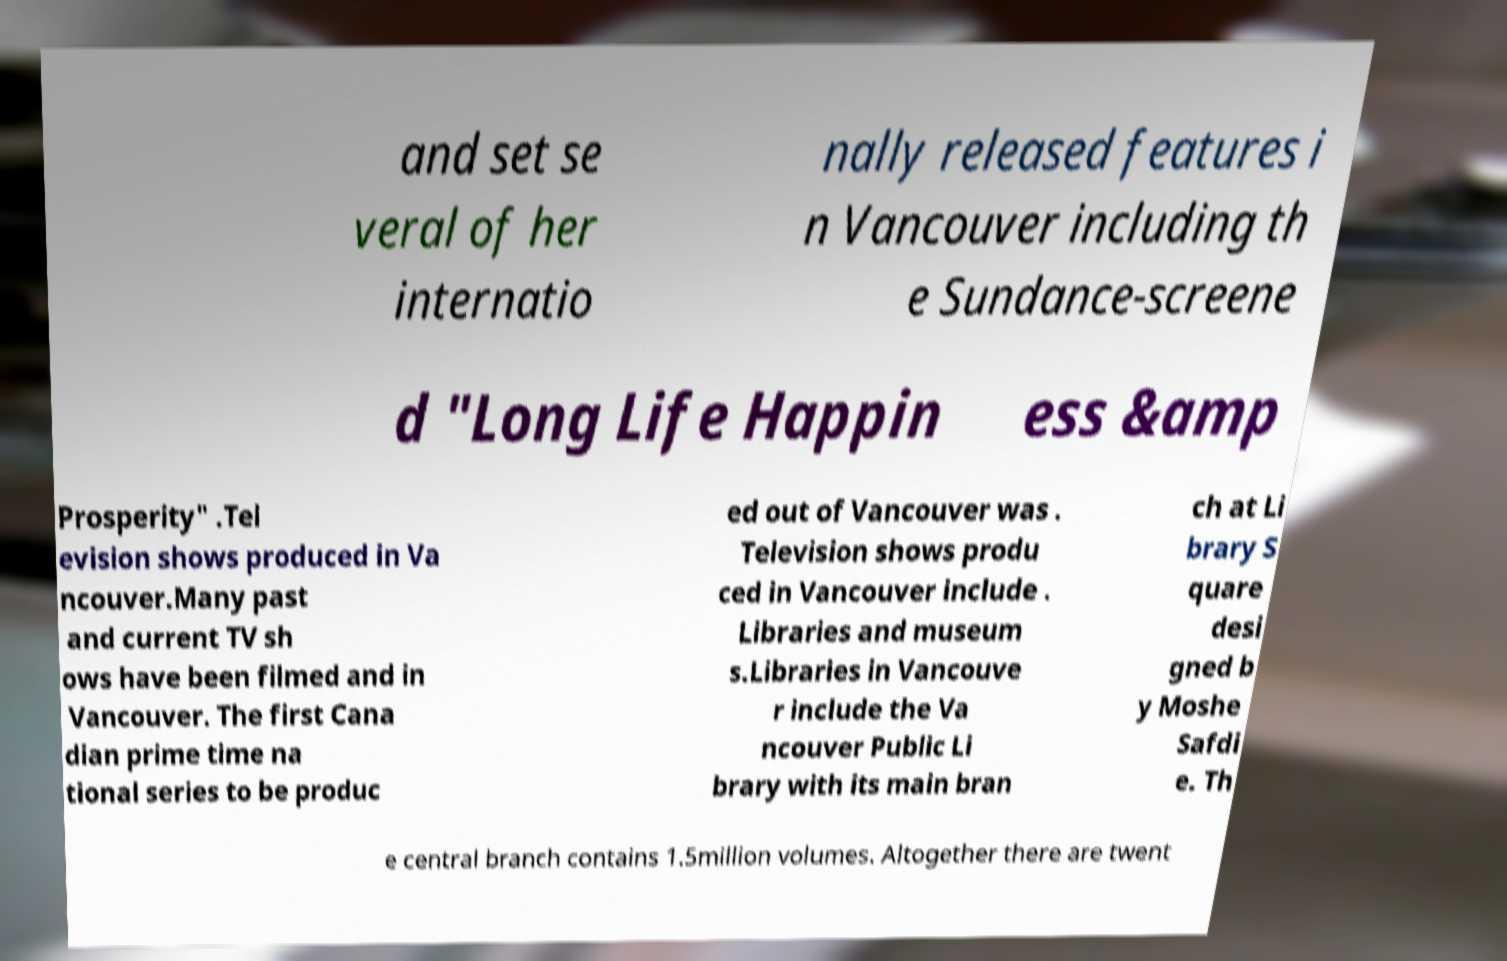What messages or text are displayed in this image? I need them in a readable, typed format. and set se veral of her internatio nally released features i n Vancouver including th e Sundance-screene d "Long Life Happin ess &amp Prosperity" .Tel evision shows produced in Va ncouver.Many past and current TV sh ows have been filmed and in Vancouver. The first Cana dian prime time na tional series to be produc ed out of Vancouver was . Television shows produ ced in Vancouver include . Libraries and museum s.Libraries in Vancouve r include the Va ncouver Public Li brary with its main bran ch at Li brary S quare desi gned b y Moshe Safdi e. Th e central branch contains 1.5million volumes. Altogether there are twent 